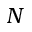Convert formula to latex. <formula><loc_0><loc_0><loc_500><loc_500>N</formula> 